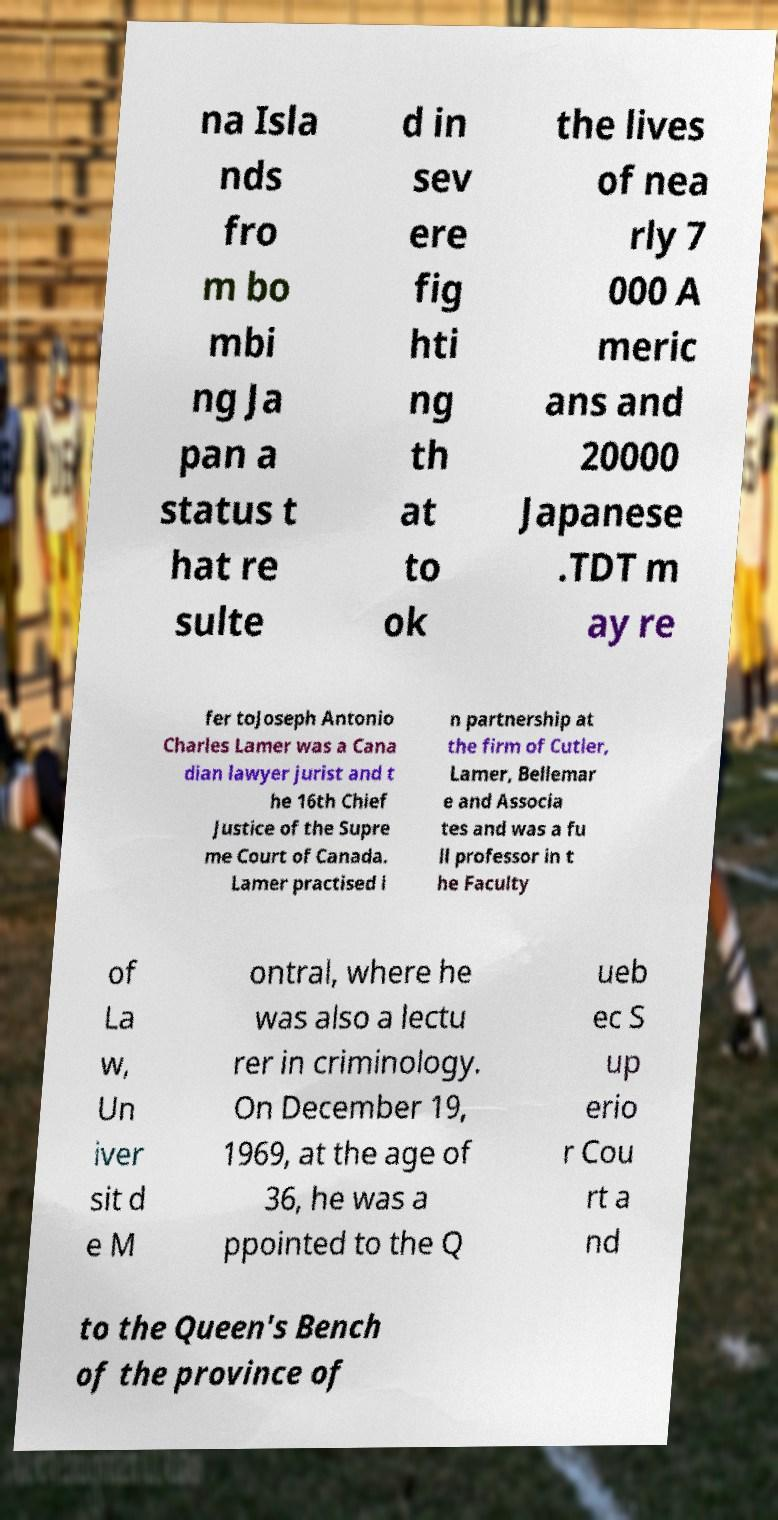I need the written content from this picture converted into text. Can you do that? na Isla nds fro m bo mbi ng Ja pan a status t hat re sulte d in sev ere fig hti ng th at to ok the lives of nea rly 7 000 A meric ans and 20000 Japanese .TDT m ay re fer toJoseph Antonio Charles Lamer was a Cana dian lawyer jurist and t he 16th Chief Justice of the Supre me Court of Canada. Lamer practised i n partnership at the firm of Cutler, Lamer, Bellemar e and Associa tes and was a fu ll professor in t he Faculty of La w, Un iver sit d e M ontral, where he was also a lectu rer in criminology. On December 19, 1969, at the age of 36, he was a ppointed to the Q ueb ec S up erio r Cou rt a nd to the Queen's Bench of the province of 